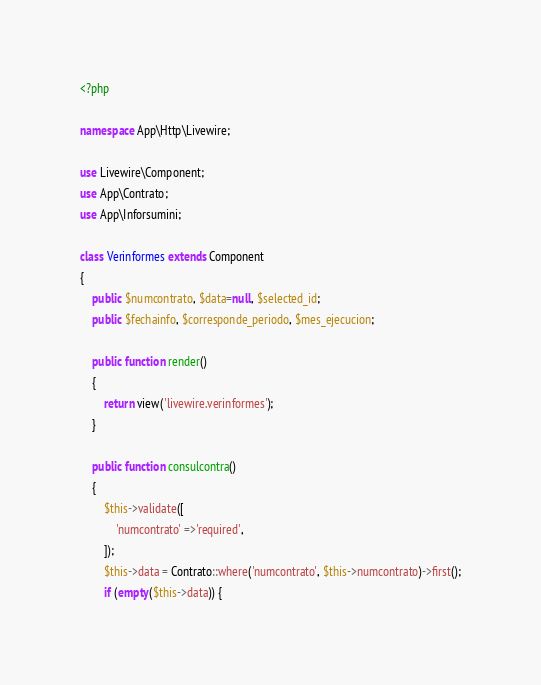<code> <loc_0><loc_0><loc_500><loc_500><_PHP_><?php

namespace App\Http\Livewire;

use Livewire\Component;
use App\Contrato;
use App\Inforsumini;

class Verinformes extends Component
{
    public $numcontrato, $data=null, $selected_id;
    public $fechainfo, $corresponde_periodo, $mes_ejecucion;

    public function render()
    {
        return view('livewire.verinformes');
    }

    public function consulcontra()
    {
        $this->validate([
            'numcontrato' =>'required',
        ]);
        $this->data = Contrato::where('numcontrato', $this->numcontrato)->first();
        if (empty($this->data)) {
</code> 